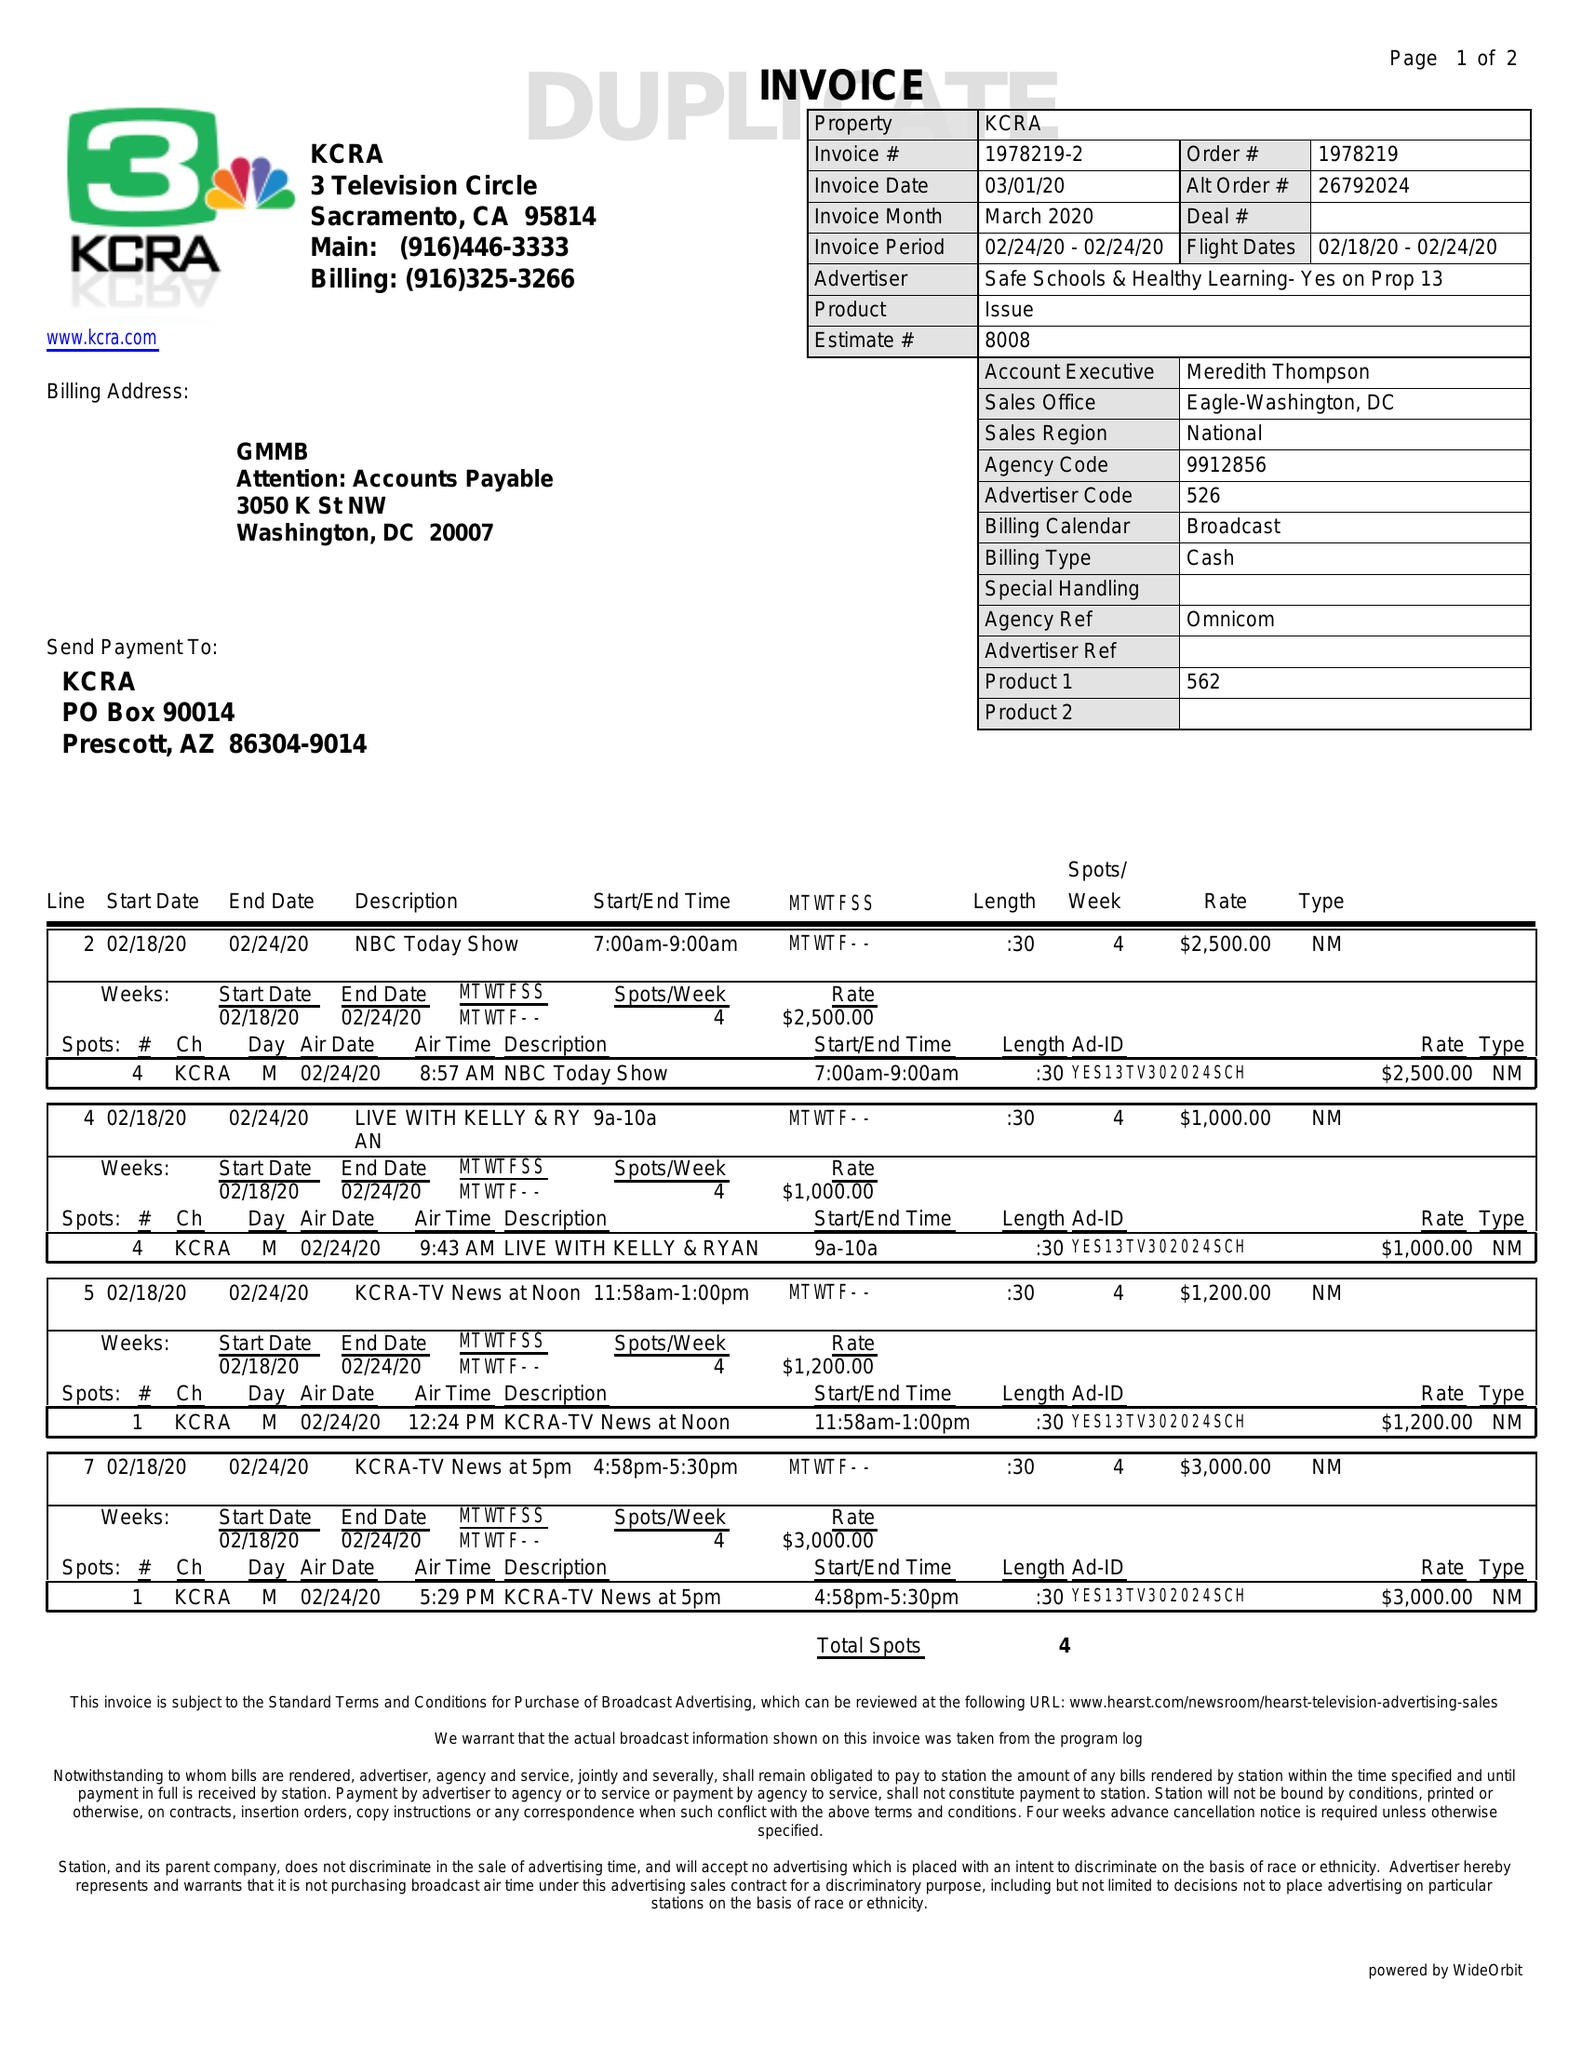What is the value for the flight_to?
Answer the question using a single word or phrase. 02/24/20 